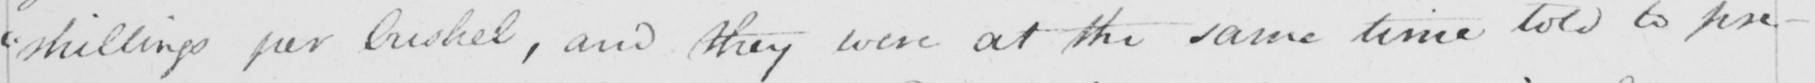Please transcribe the handwritten text in this image. " shillings per bushel , and they were at the same time told to pre- 